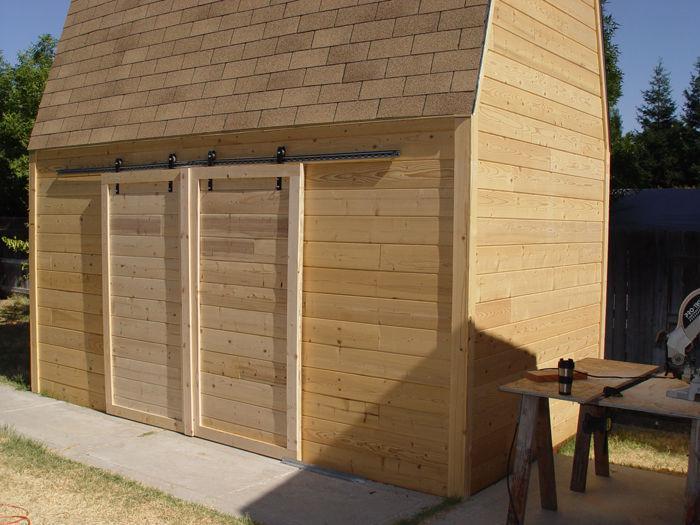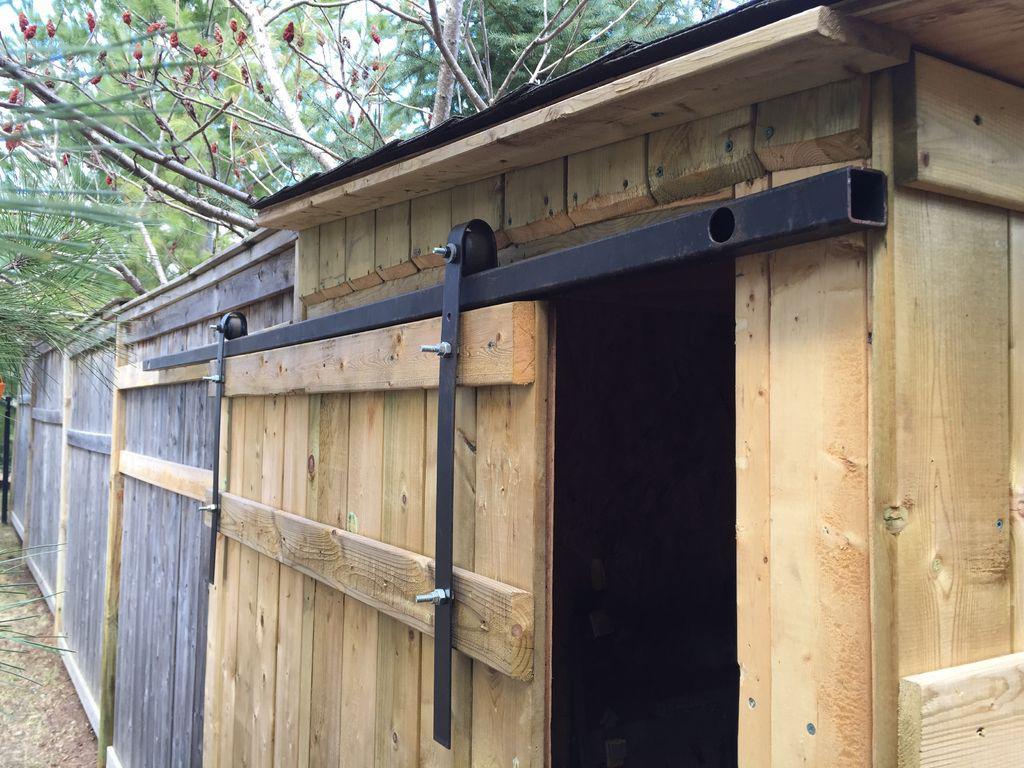The first image is the image on the left, the second image is the image on the right. Examine the images to the left and right. Is the description "An image depicts a barn door with diagonal crossed boards on the front." accurate? Answer yes or no. No. 